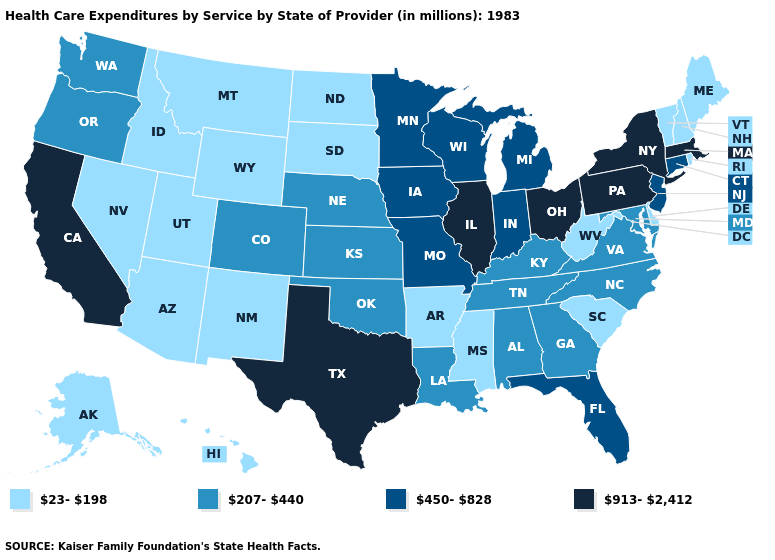Name the states that have a value in the range 450-828?
Answer briefly. Connecticut, Florida, Indiana, Iowa, Michigan, Minnesota, Missouri, New Jersey, Wisconsin. How many symbols are there in the legend?
Concise answer only. 4. What is the value of Illinois?
Be succinct. 913-2,412. What is the highest value in states that border Illinois?
Concise answer only. 450-828. Name the states that have a value in the range 913-2,412?
Keep it brief. California, Illinois, Massachusetts, New York, Ohio, Pennsylvania, Texas. What is the value of Louisiana?
Write a very short answer. 207-440. Among the states that border Tennessee , which have the highest value?
Be succinct. Missouri. What is the lowest value in the South?
Short answer required. 23-198. What is the value of Georgia?
Short answer required. 207-440. Name the states that have a value in the range 913-2,412?
Answer briefly. California, Illinois, Massachusetts, New York, Ohio, Pennsylvania, Texas. What is the highest value in the USA?
Keep it brief. 913-2,412. Does Maine have a lower value than Idaho?
Concise answer only. No. Does Nebraska have the same value as South Carolina?
Short answer required. No. Does Colorado have the lowest value in the USA?
Be succinct. No. 